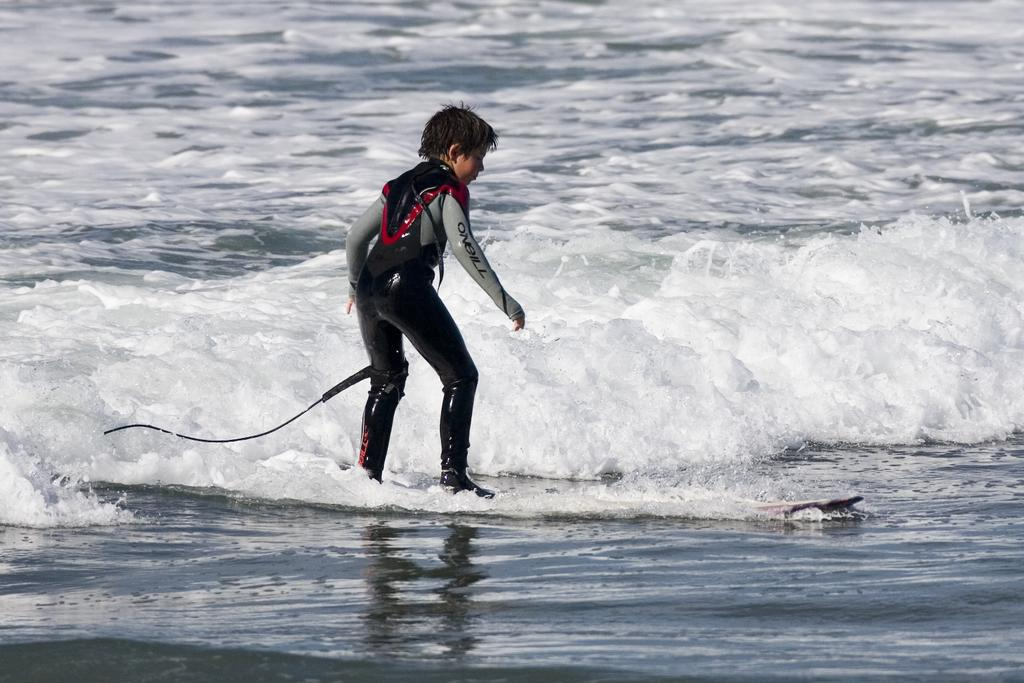Provide a one-sentence caption for the provided image. A child in an O'neill wetsuit is surfing a wave. 